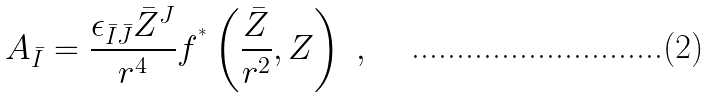<formula> <loc_0><loc_0><loc_500><loc_500>A _ { \bar { I } } = \frac { \epsilon _ { \bar { I } \bar { J } } \bar { Z } ^ { J } } { r ^ { 4 } } f ^ { ^ { * } } \left ( \frac { \bar { Z } } { r ^ { 2 } } , Z \right ) \ ,</formula> 